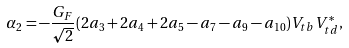Convert formula to latex. <formula><loc_0><loc_0><loc_500><loc_500>\alpha _ { 2 } = - \frac { G _ { F } } { \sqrt { 2 } } ( 2 a _ { 3 } + 2 a _ { 4 } + 2 a _ { 5 } - a _ { 7 } - a _ { 9 } - a _ { 1 0 } ) V _ { t b } V _ { t d } ^ { * } ,</formula> 